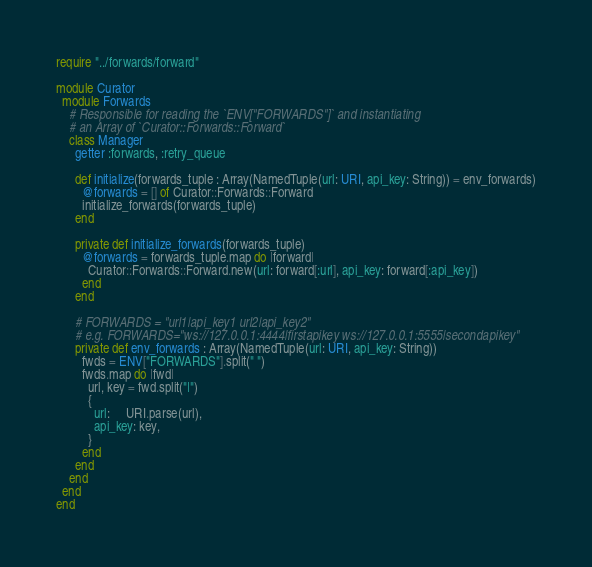<code> <loc_0><loc_0><loc_500><loc_500><_Crystal_>require "../forwards/forward"

module Curator
  module Forwards
    # Responsible for reading the `ENV["FORWARDS"]` and instantiating
    # an Array of `Curator::Forwards::Forward`
    class Manager
      getter :forwards, :retry_queue

      def initialize(forwards_tuple : Array(NamedTuple(url: URI, api_key: String)) = env_forwards)
        @forwards = [] of Curator::Forwards::Forward
        initialize_forwards(forwards_tuple)
      end

      private def initialize_forwards(forwards_tuple)
        @forwards = forwards_tuple.map do |forward|
          Curator::Forwards::Forward.new(url: forward[:url], api_key: forward[:api_key])
        end
      end

      # FORWARDS = "url1|api_key1 url2|api_key2"
      # e.g. FORWARDS="ws://127.0.0.1:4444|firstapikey ws://127.0.0.1:5555|secondapikey"
      private def env_forwards : Array(NamedTuple(url: URI, api_key: String))
        fwds = ENV["FORWARDS"].split(" ")
        fwds.map do |fwd|
          url, key = fwd.split("|")
          {
            url:     URI.parse(url),
            api_key: key,
          }
        end
      end
    end
  end
end
</code> 